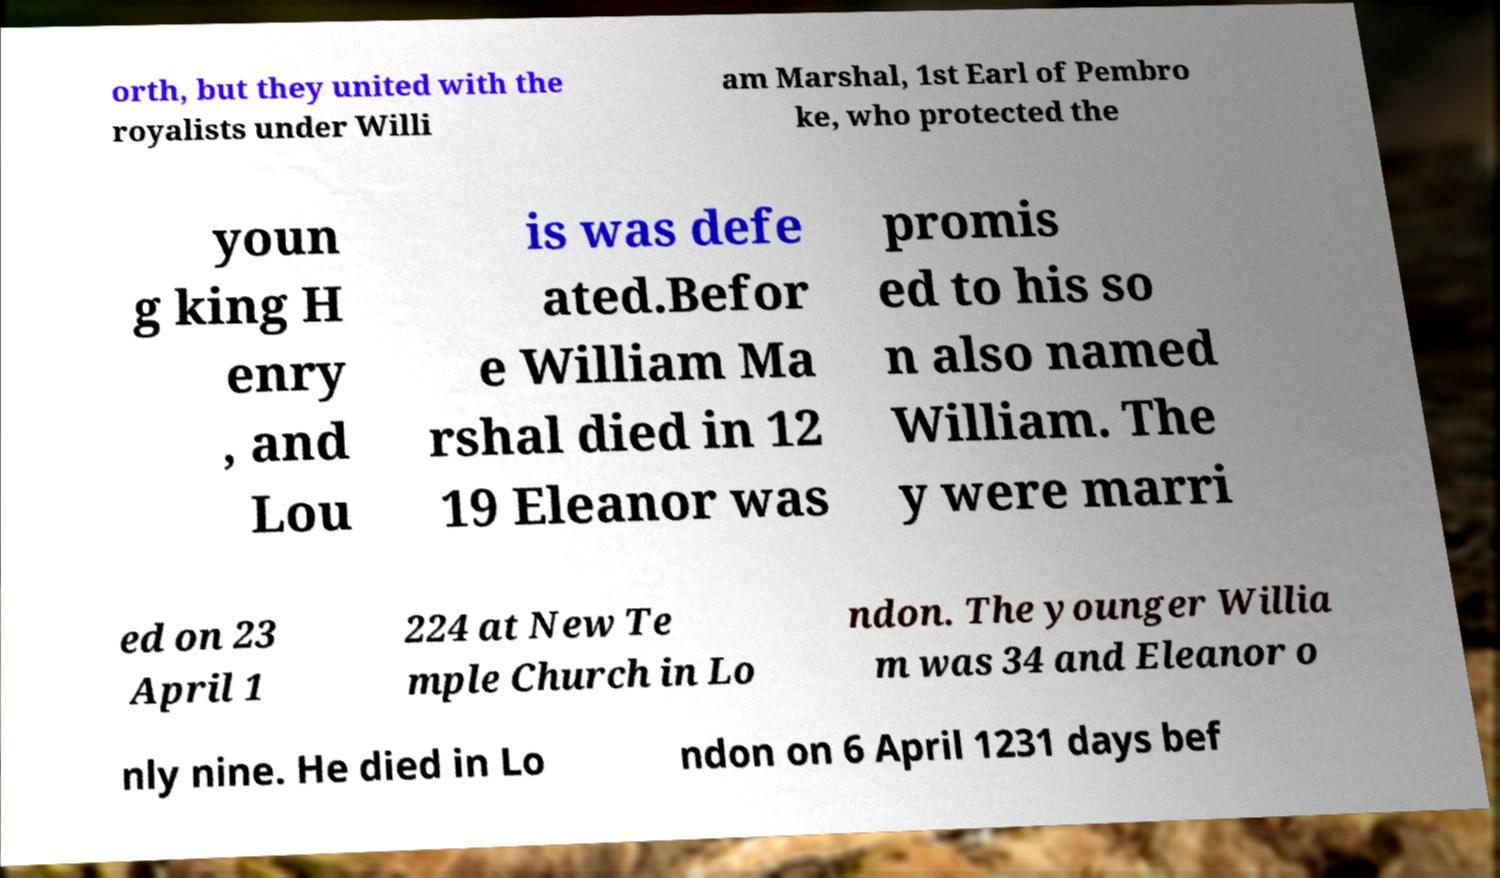Please read and relay the text visible in this image. What does it say? orth, but they united with the royalists under Willi am Marshal, 1st Earl of Pembro ke, who protected the youn g king H enry , and Lou is was defe ated.Befor e William Ma rshal died in 12 19 Eleanor was promis ed to his so n also named William. The y were marri ed on 23 April 1 224 at New Te mple Church in Lo ndon. The younger Willia m was 34 and Eleanor o nly nine. He died in Lo ndon on 6 April 1231 days bef 